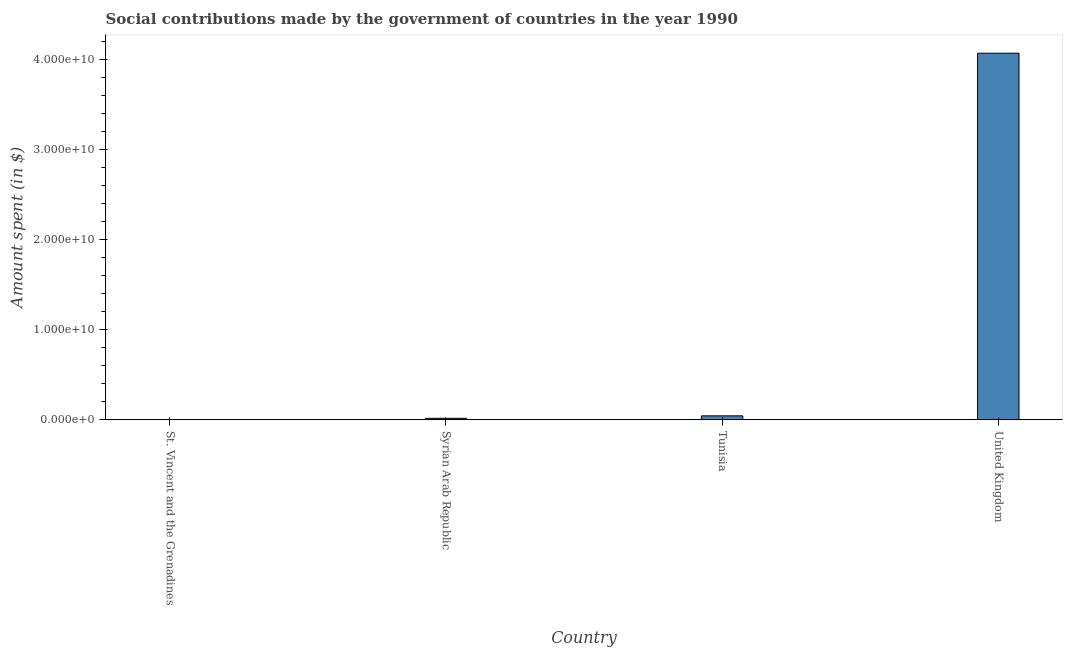Does the graph contain any zero values?
Provide a succinct answer. No. What is the title of the graph?
Offer a very short reply. Social contributions made by the government of countries in the year 1990. What is the label or title of the Y-axis?
Offer a terse response. Amount spent (in $). What is the amount spent in making social contributions in Tunisia?
Offer a terse response. 4.39e+08. Across all countries, what is the maximum amount spent in making social contributions?
Ensure brevity in your answer.  4.07e+1. Across all countries, what is the minimum amount spent in making social contributions?
Your answer should be very brief. 1.00e+05. In which country was the amount spent in making social contributions maximum?
Provide a short and direct response. United Kingdom. In which country was the amount spent in making social contributions minimum?
Offer a terse response. St. Vincent and the Grenadines. What is the sum of the amount spent in making social contributions?
Keep it short and to the point. 4.13e+1. What is the difference between the amount spent in making social contributions in St. Vincent and the Grenadines and Tunisia?
Your response must be concise. -4.39e+08. What is the average amount spent in making social contributions per country?
Your response must be concise. 1.03e+1. What is the median amount spent in making social contributions?
Make the answer very short. 3.02e+08. What is the ratio of the amount spent in making social contributions in Tunisia to that in United Kingdom?
Provide a short and direct response. 0.01. Is the amount spent in making social contributions in Tunisia less than that in United Kingdom?
Give a very brief answer. Yes. What is the difference between the highest and the second highest amount spent in making social contributions?
Provide a short and direct response. 4.02e+1. What is the difference between the highest and the lowest amount spent in making social contributions?
Keep it short and to the point. 4.07e+1. In how many countries, is the amount spent in making social contributions greater than the average amount spent in making social contributions taken over all countries?
Ensure brevity in your answer.  1. Are all the bars in the graph horizontal?
Give a very brief answer. No. What is the difference between two consecutive major ticks on the Y-axis?
Offer a terse response. 1.00e+1. Are the values on the major ticks of Y-axis written in scientific E-notation?
Make the answer very short. Yes. What is the Amount spent (in $) of St. Vincent and the Grenadines?
Give a very brief answer. 1.00e+05. What is the Amount spent (in $) of Syrian Arab Republic?
Your answer should be compact. 1.65e+08. What is the Amount spent (in $) of Tunisia?
Make the answer very short. 4.39e+08. What is the Amount spent (in $) of United Kingdom?
Keep it short and to the point. 4.07e+1. What is the difference between the Amount spent (in $) in St. Vincent and the Grenadines and Syrian Arab Republic?
Keep it short and to the point. -1.65e+08. What is the difference between the Amount spent (in $) in St. Vincent and the Grenadines and Tunisia?
Offer a very short reply. -4.39e+08. What is the difference between the Amount spent (in $) in St. Vincent and the Grenadines and United Kingdom?
Ensure brevity in your answer.  -4.07e+1. What is the difference between the Amount spent (in $) in Syrian Arab Republic and Tunisia?
Make the answer very short. -2.74e+08. What is the difference between the Amount spent (in $) in Syrian Arab Republic and United Kingdom?
Give a very brief answer. -4.05e+1. What is the difference between the Amount spent (in $) in Tunisia and United Kingdom?
Ensure brevity in your answer.  -4.02e+1. What is the ratio of the Amount spent (in $) in Syrian Arab Republic to that in Tunisia?
Your response must be concise. 0.38. What is the ratio of the Amount spent (in $) in Syrian Arab Republic to that in United Kingdom?
Ensure brevity in your answer.  0. What is the ratio of the Amount spent (in $) in Tunisia to that in United Kingdom?
Your answer should be compact. 0.01. 